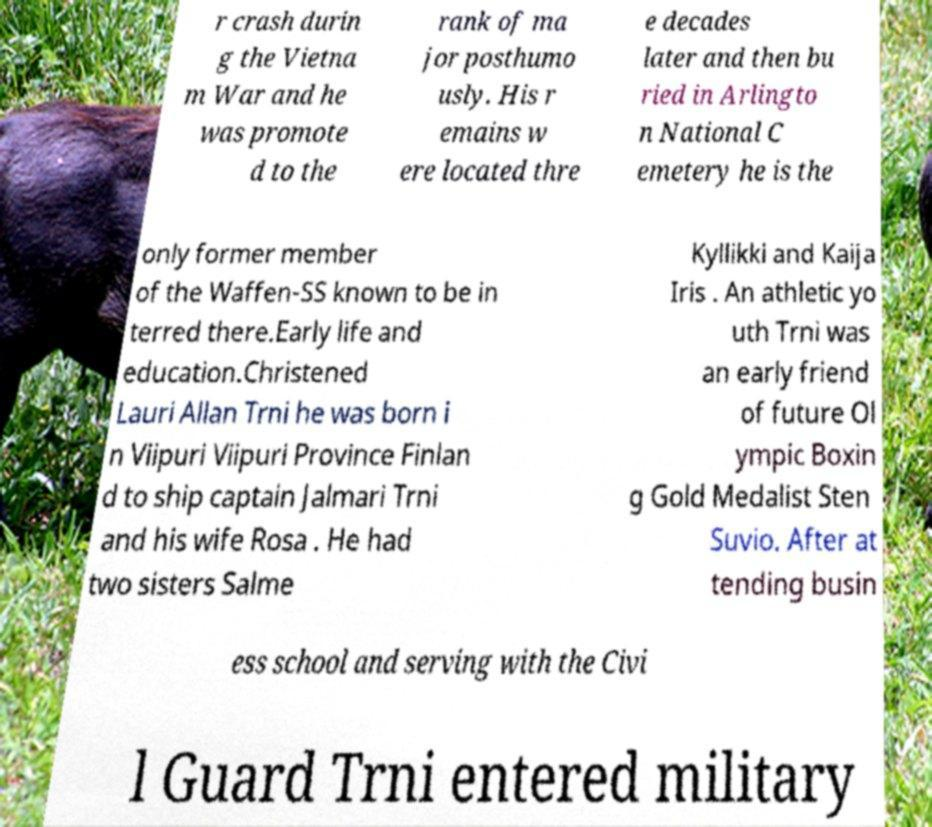Could you extract and type out the text from this image? r crash durin g the Vietna m War and he was promote d to the rank of ma jor posthumo usly. His r emains w ere located thre e decades later and then bu ried in Arlingto n National C emetery he is the only former member of the Waffen-SS known to be in terred there.Early life and education.Christened Lauri Allan Trni he was born i n Viipuri Viipuri Province Finlan d to ship captain Jalmari Trni and his wife Rosa . He had two sisters Salme Kyllikki and Kaija Iris . An athletic yo uth Trni was an early friend of future Ol ympic Boxin g Gold Medalist Sten Suvio. After at tending busin ess school and serving with the Civi l Guard Trni entered military 